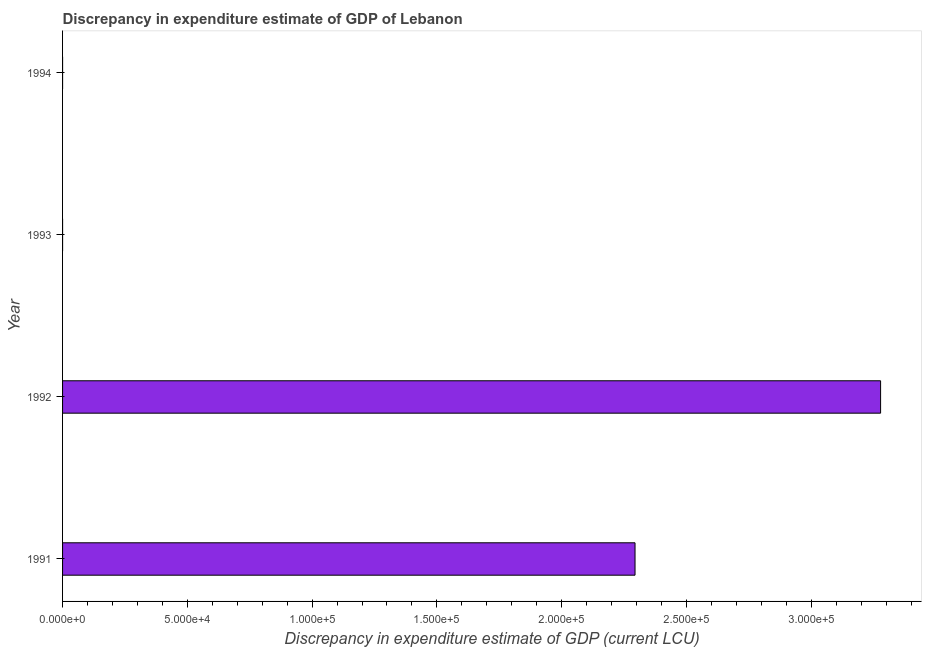What is the title of the graph?
Offer a terse response. Discrepancy in expenditure estimate of GDP of Lebanon. What is the label or title of the X-axis?
Your answer should be compact. Discrepancy in expenditure estimate of GDP (current LCU). What is the label or title of the Y-axis?
Provide a succinct answer. Year. What is the discrepancy in expenditure estimate of gdp in 1994?
Provide a short and direct response. 0. Across all years, what is the maximum discrepancy in expenditure estimate of gdp?
Your answer should be very brief. 3.28e+05. Across all years, what is the minimum discrepancy in expenditure estimate of gdp?
Your response must be concise. 0. In which year was the discrepancy in expenditure estimate of gdp minimum?
Offer a very short reply. 1993. What is the sum of the discrepancy in expenditure estimate of gdp?
Offer a terse response. 5.57e+05. What is the difference between the discrepancy in expenditure estimate of gdp in 1992 and 1993?
Make the answer very short. 3.28e+05. What is the average discrepancy in expenditure estimate of gdp per year?
Give a very brief answer. 1.39e+05. What is the median discrepancy in expenditure estimate of gdp?
Keep it short and to the point. 1.15e+05. In how many years, is the discrepancy in expenditure estimate of gdp greater than 290000 LCU?
Provide a short and direct response. 1. What is the ratio of the discrepancy in expenditure estimate of gdp in 1991 to that in 1993?
Keep it short and to the point. 1.15e+08. What is the difference between the highest and the second highest discrepancy in expenditure estimate of gdp?
Your answer should be very brief. 9.84e+04. Is the sum of the discrepancy in expenditure estimate of gdp in 1991 and 1994 greater than the maximum discrepancy in expenditure estimate of gdp across all years?
Your response must be concise. No. What is the difference between the highest and the lowest discrepancy in expenditure estimate of gdp?
Provide a succinct answer. 3.28e+05. How many bars are there?
Offer a very short reply. 4. Are all the bars in the graph horizontal?
Provide a short and direct response. Yes. How many years are there in the graph?
Your answer should be compact. 4. Are the values on the major ticks of X-axis written in scientific E-notation?
Make the answer very short. Yes. What is the Discrepancy in expenditure estimate of GDP (current LCU) in 1991?
Keep it short and to the point. 2.29e+05. What is the Discrepancy in expenditure estimate of GDP (current LCU) of 1992?
Your response must be concise. 3.28e+05. What is the Discrepancy in expenditure estimate of GDP (current LCU) in 1993?
Offer a very short reply. 0. What is the Discrepancy in expenditure estimate of GDP (current LCU) in 1994?
Give a very brief answer. 0. What is the difference between the Discrepancy in expenditure estimate of GDP (current LCU) in 1991 and 1992?
Your answer should be very brief. -9.84e+04. What is the difference between the Discrepancy in expenditure estimate of GDP (current LCU) in 1991 and 1993?
Offer a terse response. 2.29e+05. What is the difference between the Discrepancy in expenditure estimate of GDP (current LCU) in 1991 and 1994?
Your answer should be very brief. 2.29e+05. What is the difference between the Discrepancy in expenditure estimate of GDP (current LCU) in 1992 and 1993?
Your response must be concise. 3.28e+05. What is the difference between the Discrepancy in expenditure estimate of GDP (current LCU) in 1992 and 1994?
Offer a terse response. 3.28e+05. What is the ratio of the Discrepancy in expenditure estimate of GDP (current LCU) in 1991 to that in 1992?
Your response must be concise. 0.7. What is the ratio of the Discrepancy in expenditure estimate of GDP (current LCU) in 1991 to that in 1993?
Provide a short and direct response. 1.15e+08. What is the ratio of the Discrepancy in expenditure estimate of GDP (current LCU) in 1991 to that in 1994?
Your answer should be compact. 1.15e+08. What is the ratio of the Discrepancy in expenditure estimate of GDP (current LCU) in 1992 to that in 1993?
Make the answer very short. 1.64e+08. What is the ratio of the Discrepancy in expenditure estimate of GDP (current LCU) in 1992 to that in 1994?
Provide a short and direct response. 1.64e+08. What is the ratio of the Discrepancy in expenditure estimate of GDP (current LCU) in 1993 to that in 1994?
Offer a very short reply. 1. 